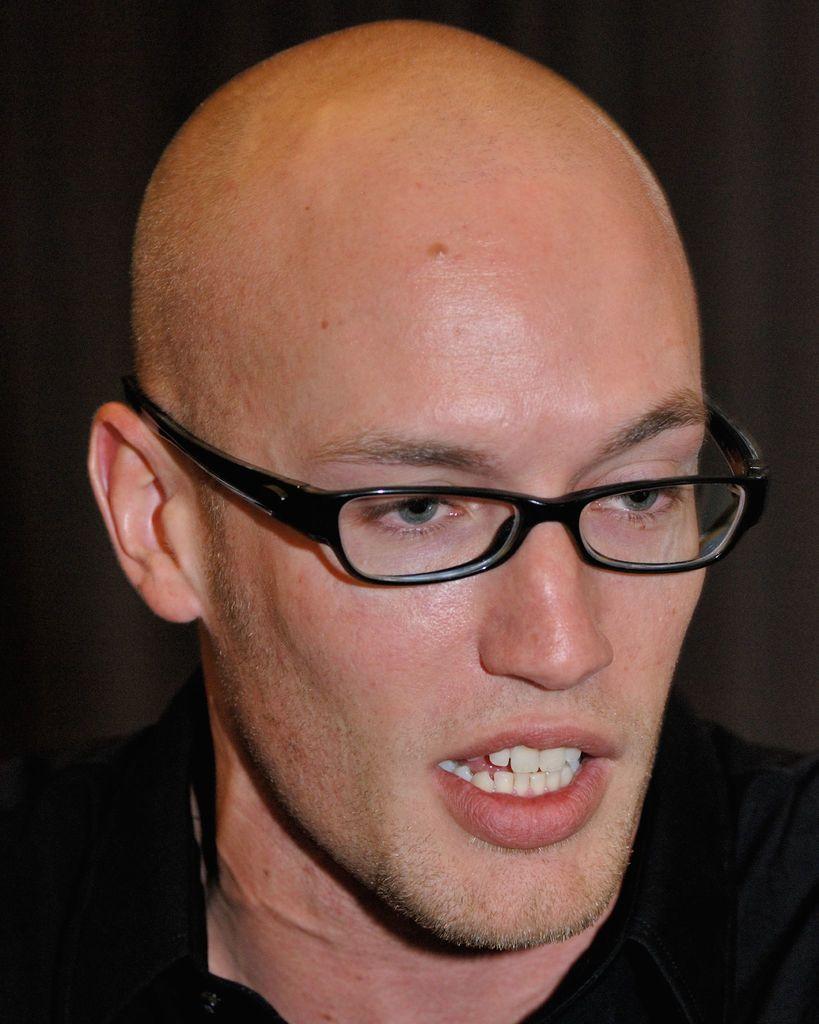Can you describe this image briefly? Here, we can see a man, he is wearing specs and there is a dark background. 